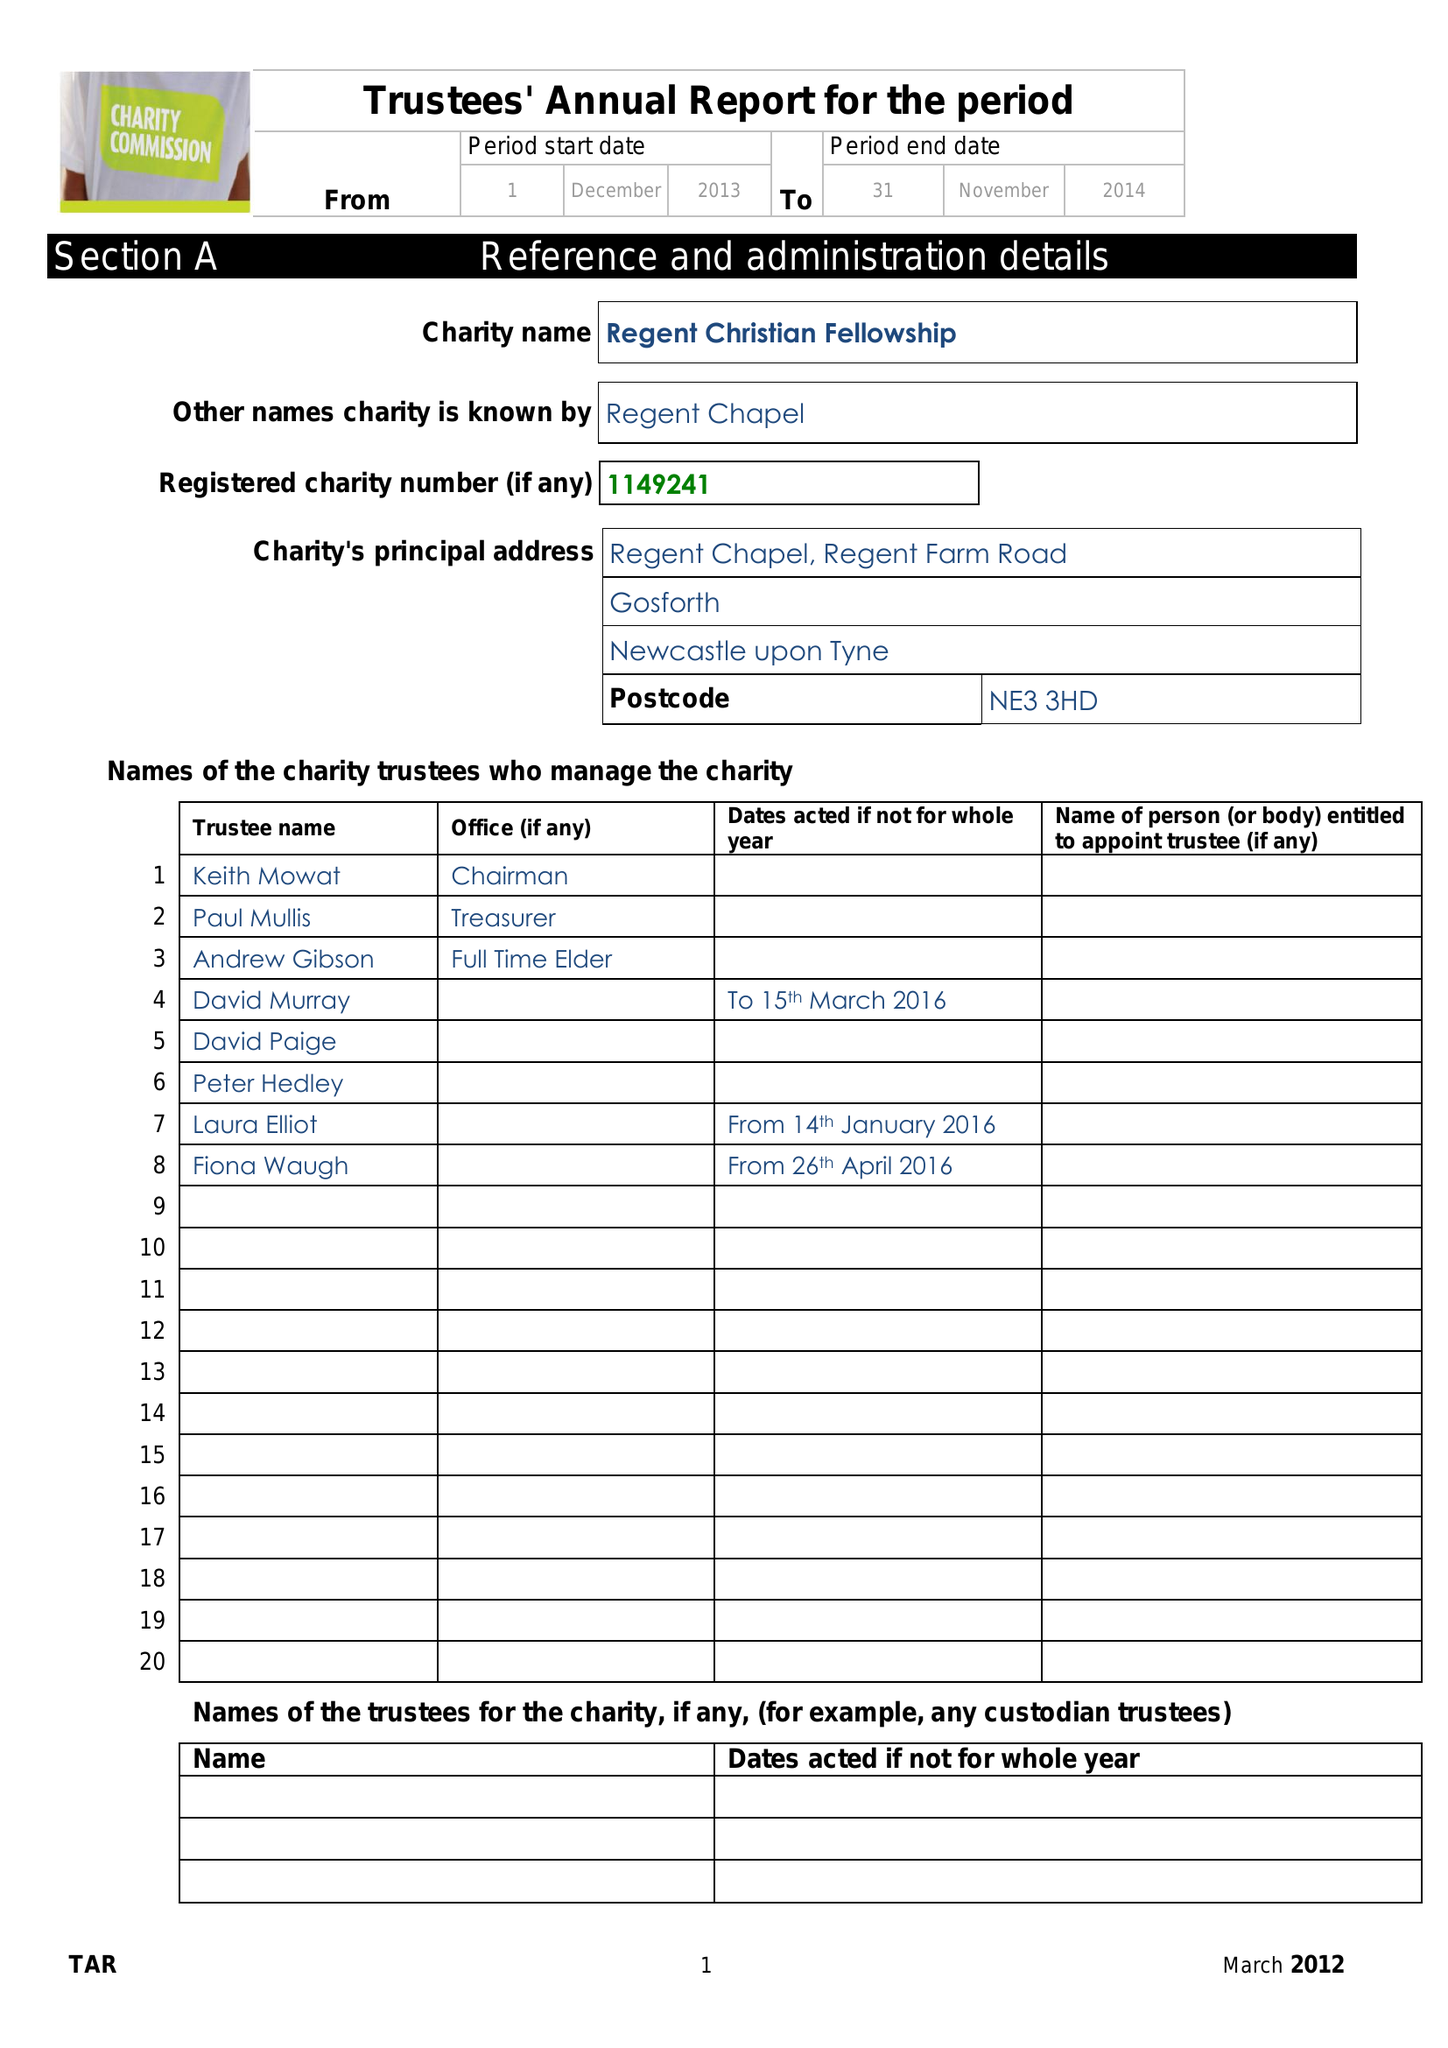What is the value for the charity_number?
Answer the question using a single word or phrase. 1149241 